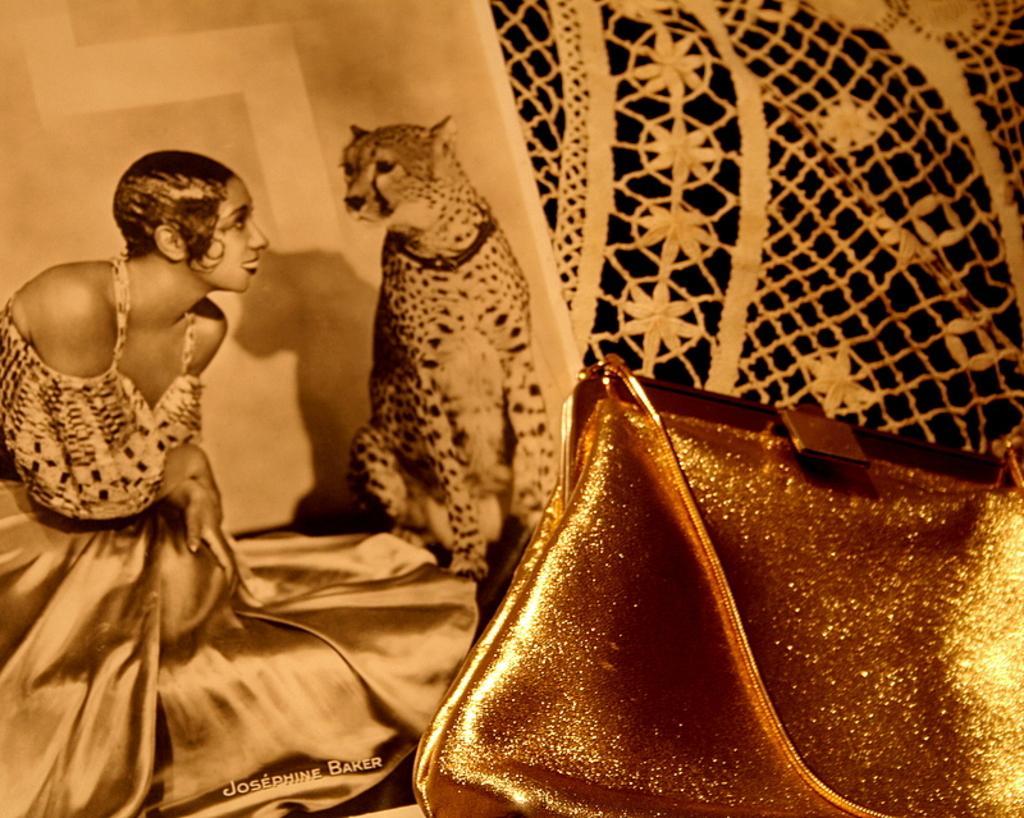Describe this image in one or two sentences. this picture shows a poster of women and a cheetah and we see a woman's handbag on the side 